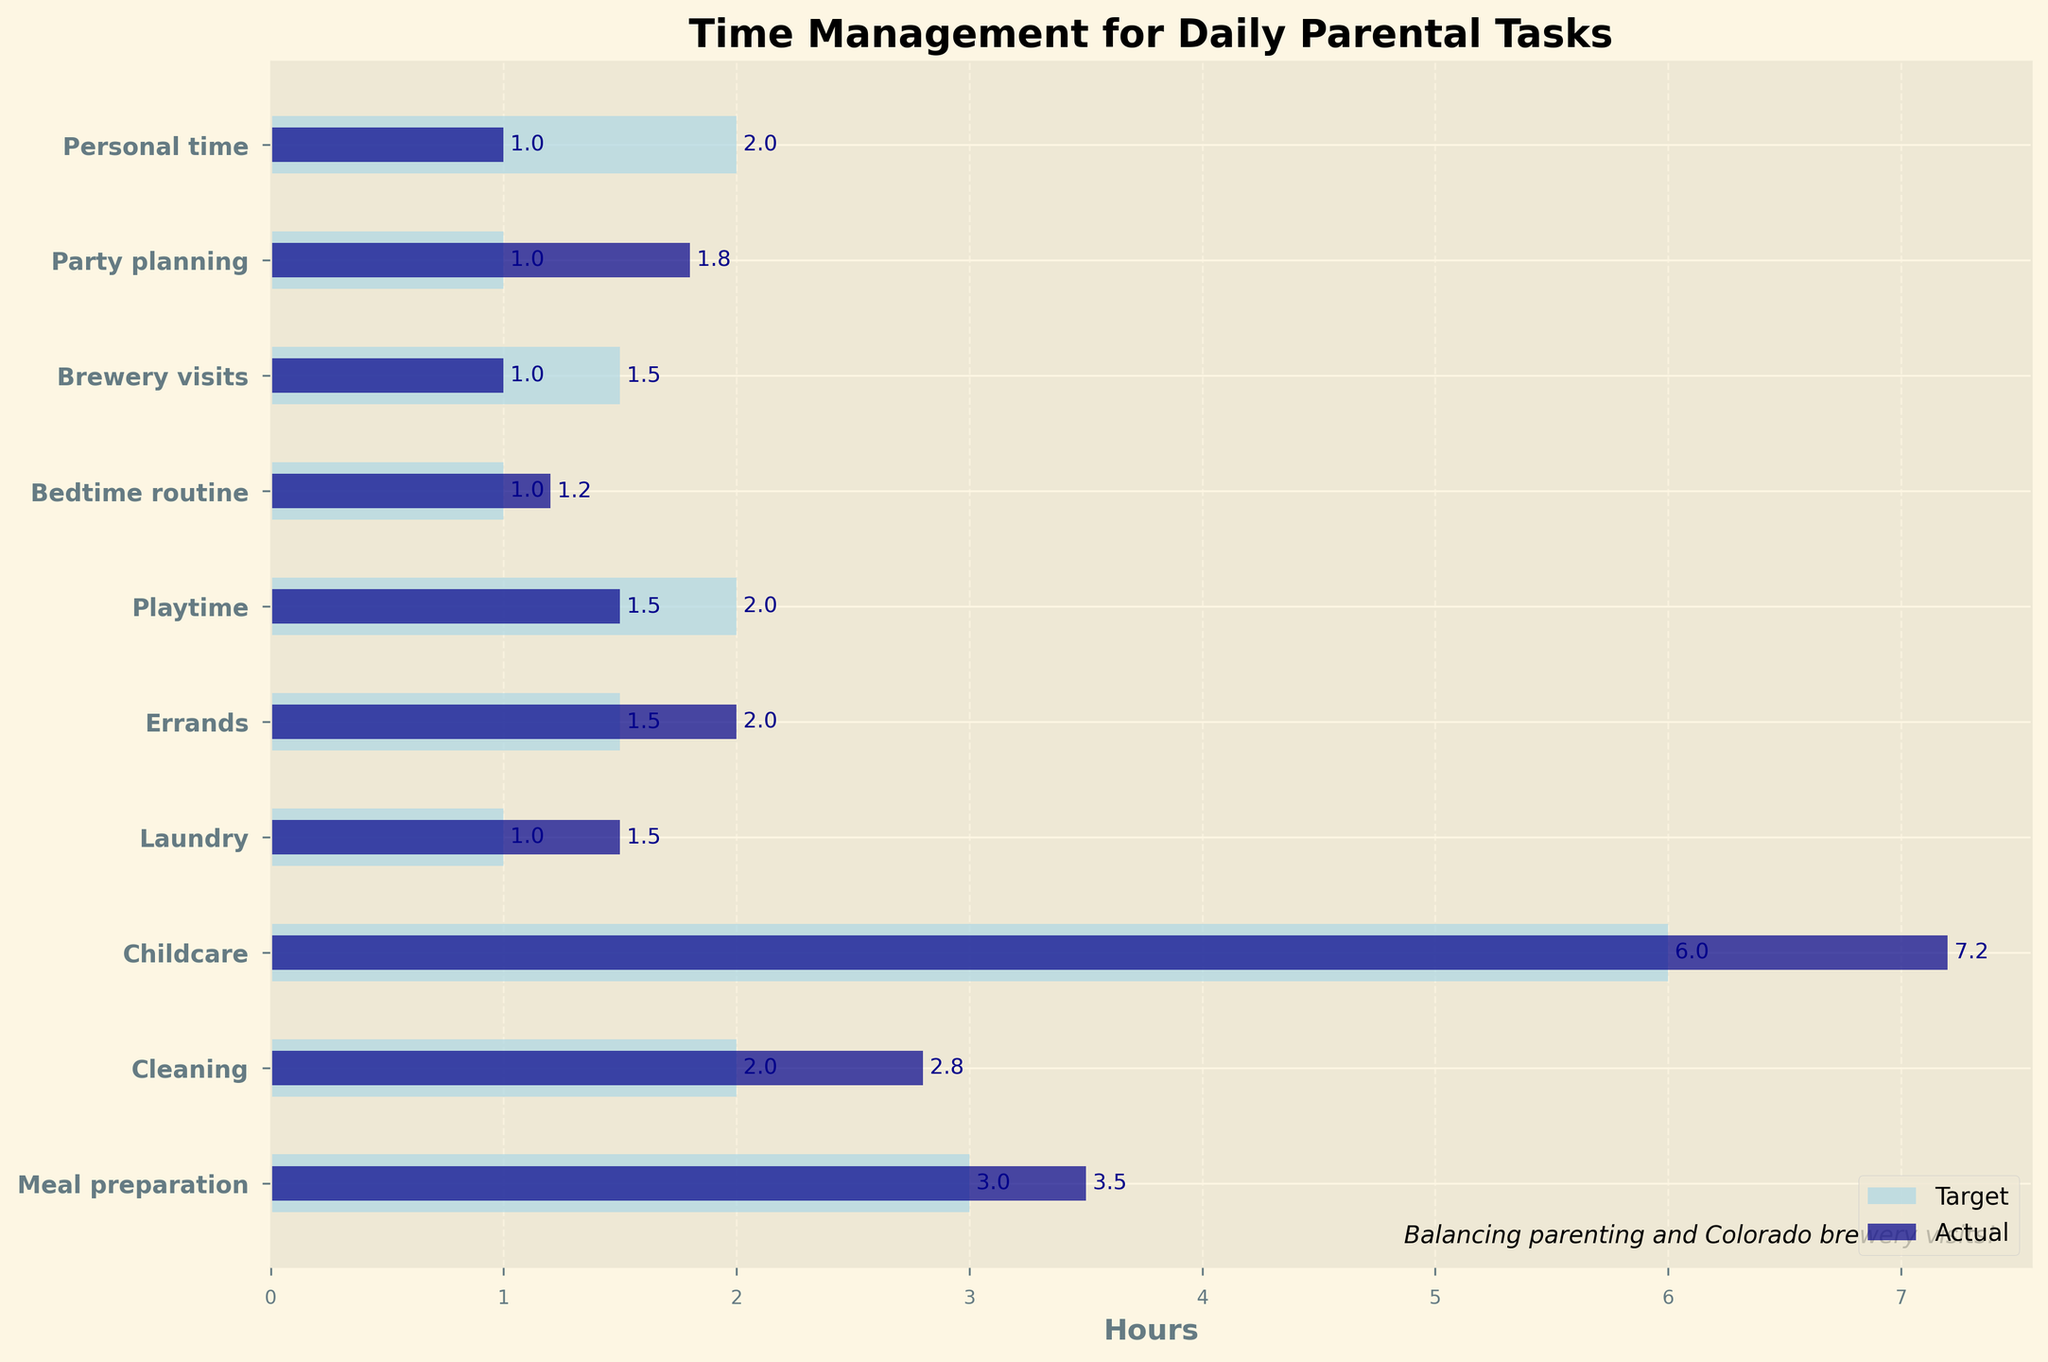What's the title of the figure? The title of the figure is positioned at the top of the plot. Titles typically describe the overall content or purpose of the figure. In this case, it indicates the main theme of the data presented.
Answer: Time Management for Daily Parental Tasks How many tasks are represented in this figure? To determine the number of tasks, count the number of horizontal bars or tasks listed on the y-axis.
Answer: 10 What task shows the largest discrepancy between target and actual hours? Compare the differences between target and actual hours for each task. The largest discrepancy is the task with the greatest gap.
Answer: Childcare What two tasks have the smallest difference between target and actual hours? Look at all the tasks and identify those where the target and actual hours are closest in value.
Answer: Meal preparation and Bedtime routine Which task has the highest number of actual hours spent? Examine the horizontal bars representing actual hours and identify the one that extends the farthest to the right.
Answer: Childcare What are the actual and target hours for Brewery visits? Locate "Brewery visits" on the y-axis, then refer to the corresponding horizontal bars for both target and actual hours.
Answer: Actual: 1, Target: 1.5 How many hours in total are spent on Cleaning and Laundry? Add the actual hours spent on Cleaning and Laundry by summing up their values.
Answer: 2.8 + 1.5 = 4.3 How much more time is spent on Childcare than Playtime? Subtract the actual hours spent on Playtime from the actual hours spent on Childcare.
Answer: 7.2 - 1.5 = 5.7 Which task is closest to its target time, excluding Meal preparation? After excluding Meal preparation, compare the actual and target hours for the other tasks and find the smallest discrepancy.
Answer: Bedtime routine Identify the task where the actual hours are below the target hours. Review the actual and target hours for each task, and identify the task where the actual hours are less than the target hours.
Answer: Brewery visits 